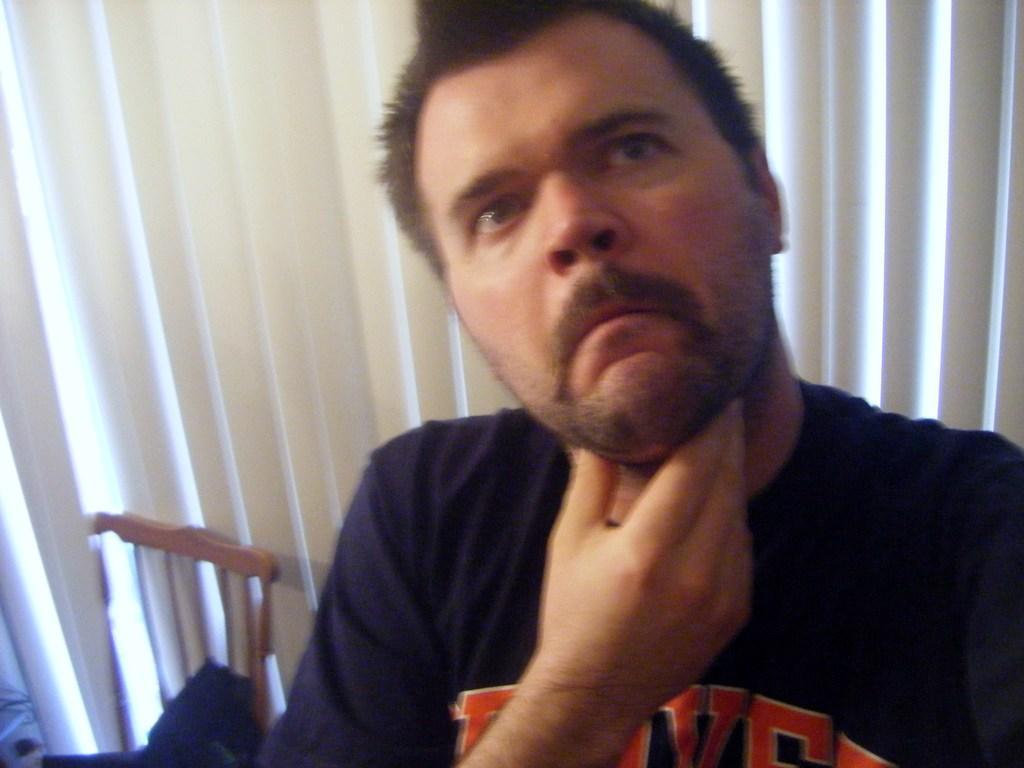How would you summarize this image in a sentence or two? This picture shows a man seated on the chair and we see another chair on the side and blinds on the back. 